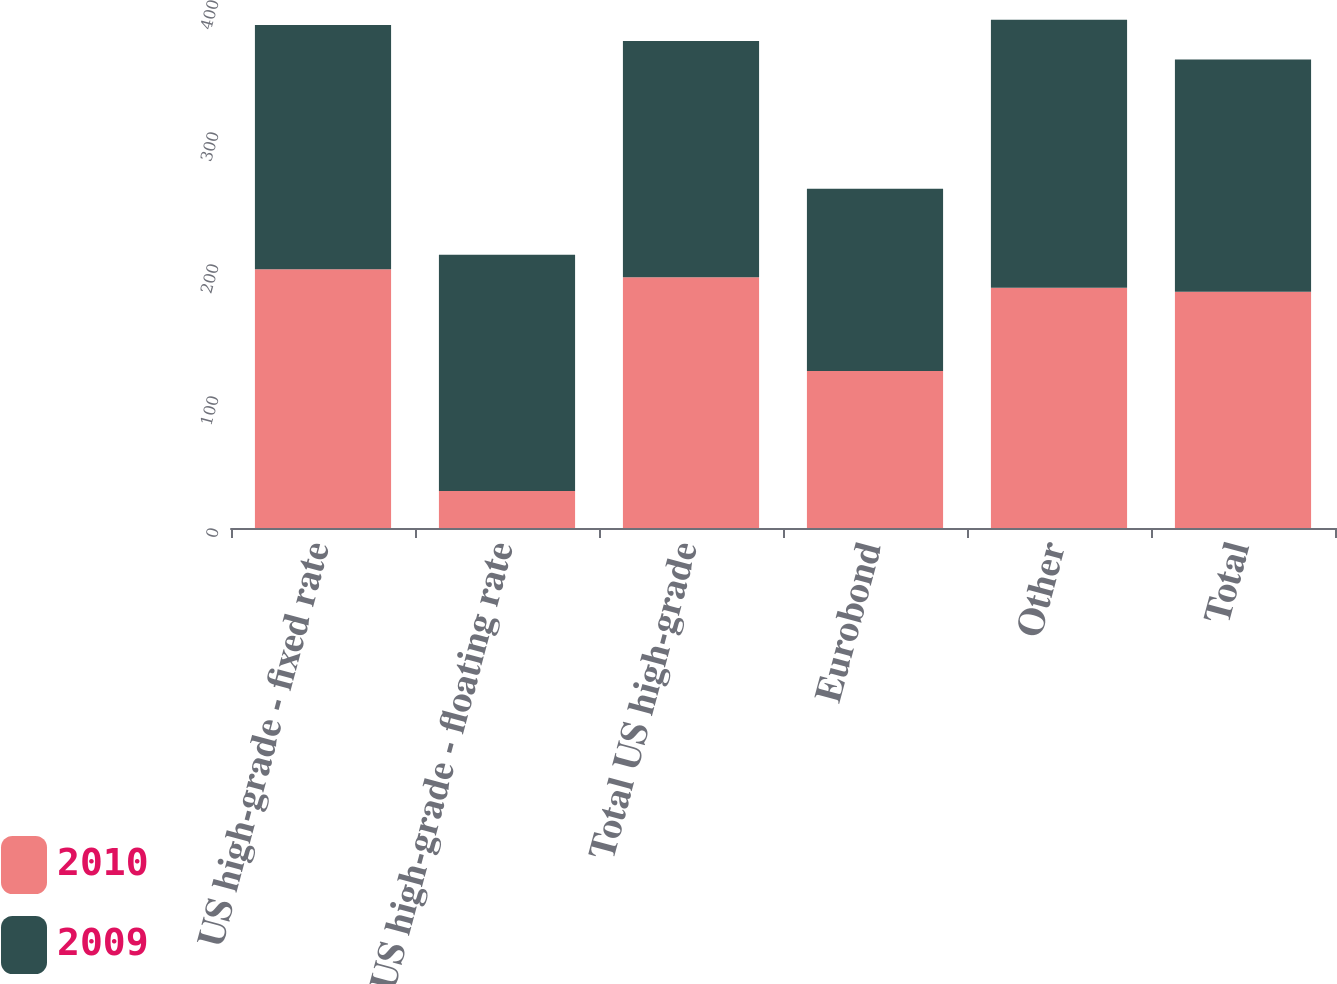Convert chart to OTSL. <chart><loc_0><loc_0><loc_500><loc_500><stacked_bar_chart><ecel><fcel>US high-grade - fixed rate<fcel>US high-grade - floating rate<fcel>Total US high-grade<fcel>Eurobond<fcel>Other<fcel>Total<nl><fcel>2010<fcel>196<fcel>28<fcel>190<fcel>119<fcel>182<fcel>179<nl><fcel>2009<fcel>185<fcel>179<fcel>179<fcel>138<fcel>203<fcel>176<nl></chart> 